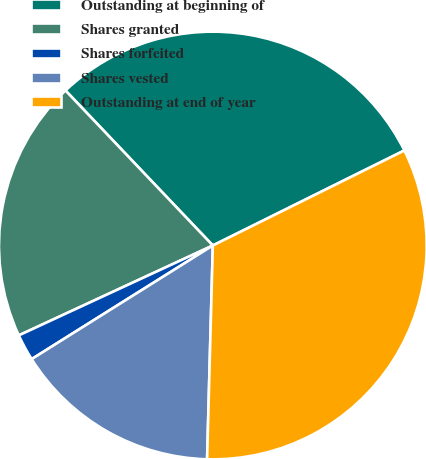Convert chart to OTSL. <chart><loc_0><loc_0><loc_500><loc_500><pie_chart><fcel>Outstanding at beginning of<fcel>Shares granted<fcel>Shares forfeited<fcel>Shares vested<fcel>Outstanding at end of year<nl><fcel>29.77%<fcel>19.81%<fcel>2.01%<fcel>15.66%<fcel>32.76%<nl></chart> 